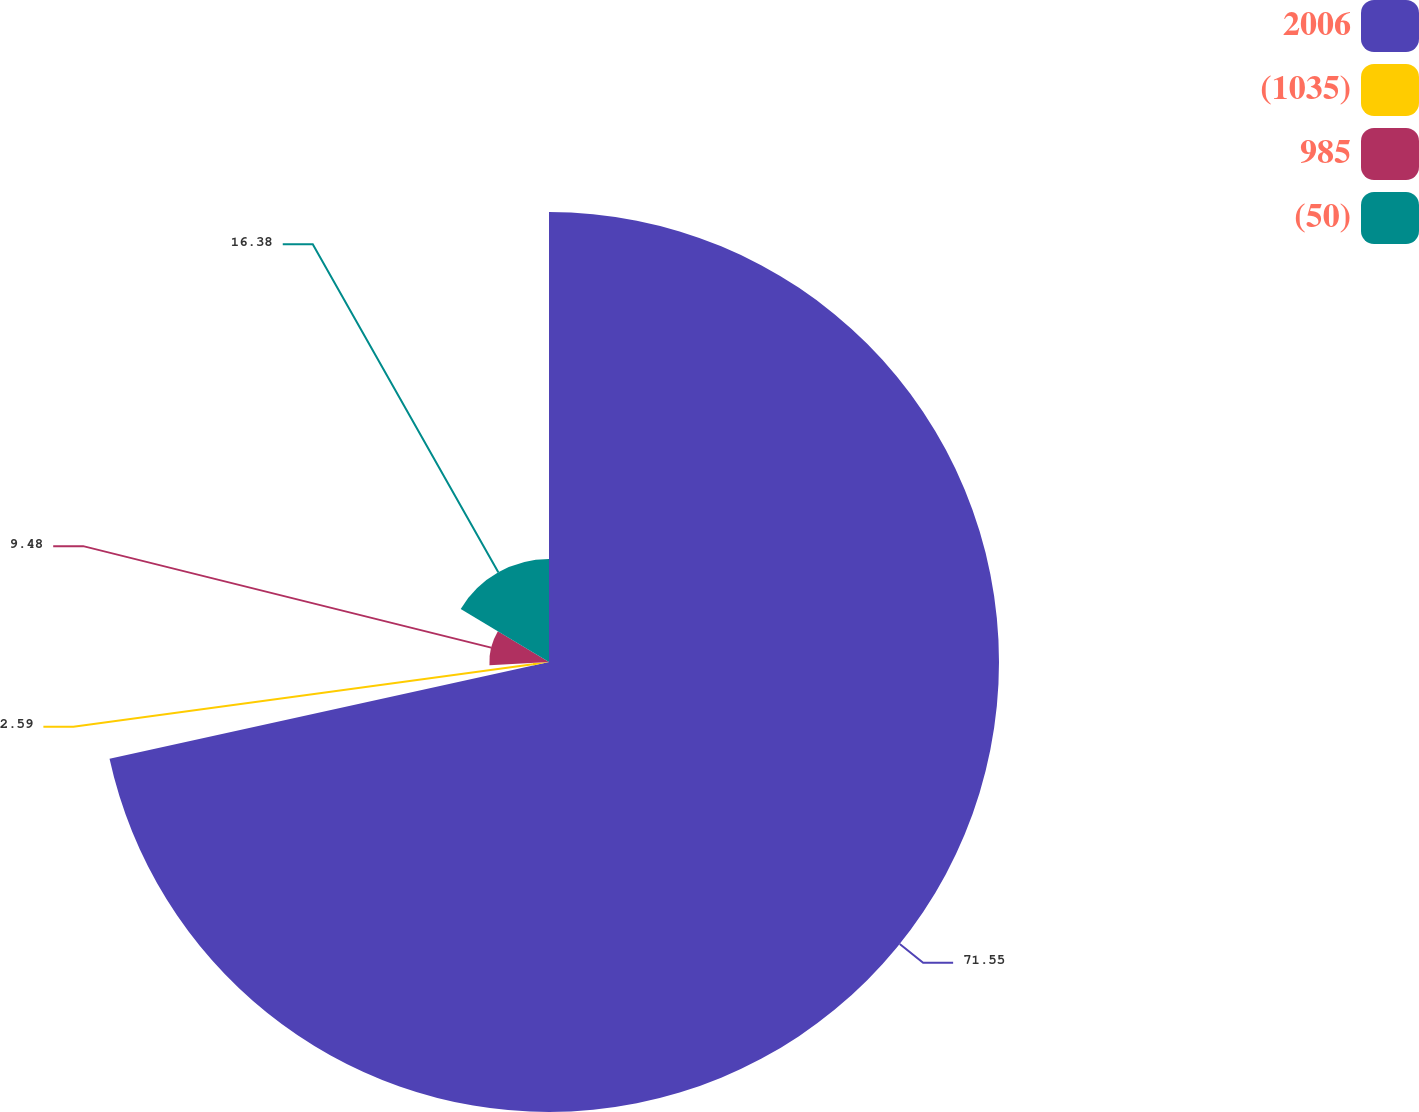<chart> <loc_0><loc_0><loc_500><loc_500><pie_chart><fcel>2006<fcel>(1035)<fcel>985<fcel>(50)<nl><fcel>71.55%<fcel>2.59%<fcel>9.48%<fcel>16.38%<nl></chart> 